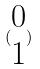Convert formula to latex. <formula><loc_0><loc_0><loc_500><loc_500>( \begin{matrix} 0 \\ 1 \end{matrix} )</formula> 